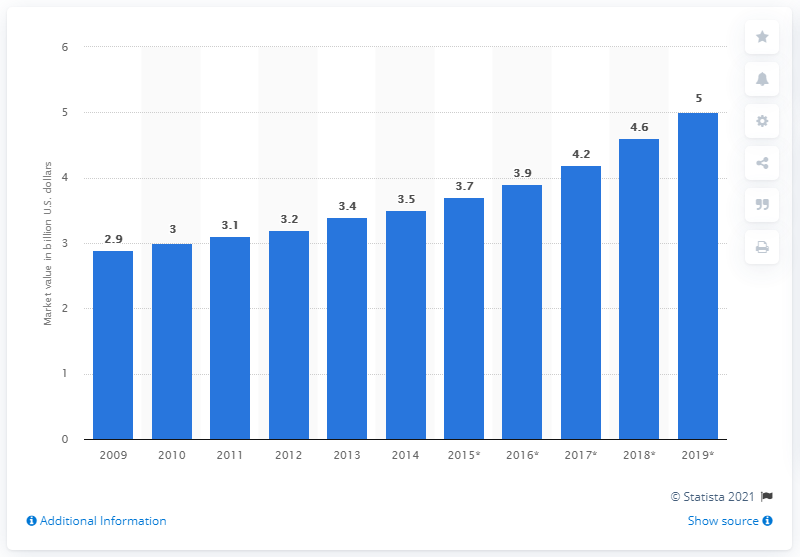Specify some key components in this picture. In 2013, the market size of the video surveillance market in EMEA (Europe, Middle East, and Africa) was approximately 3.4. 